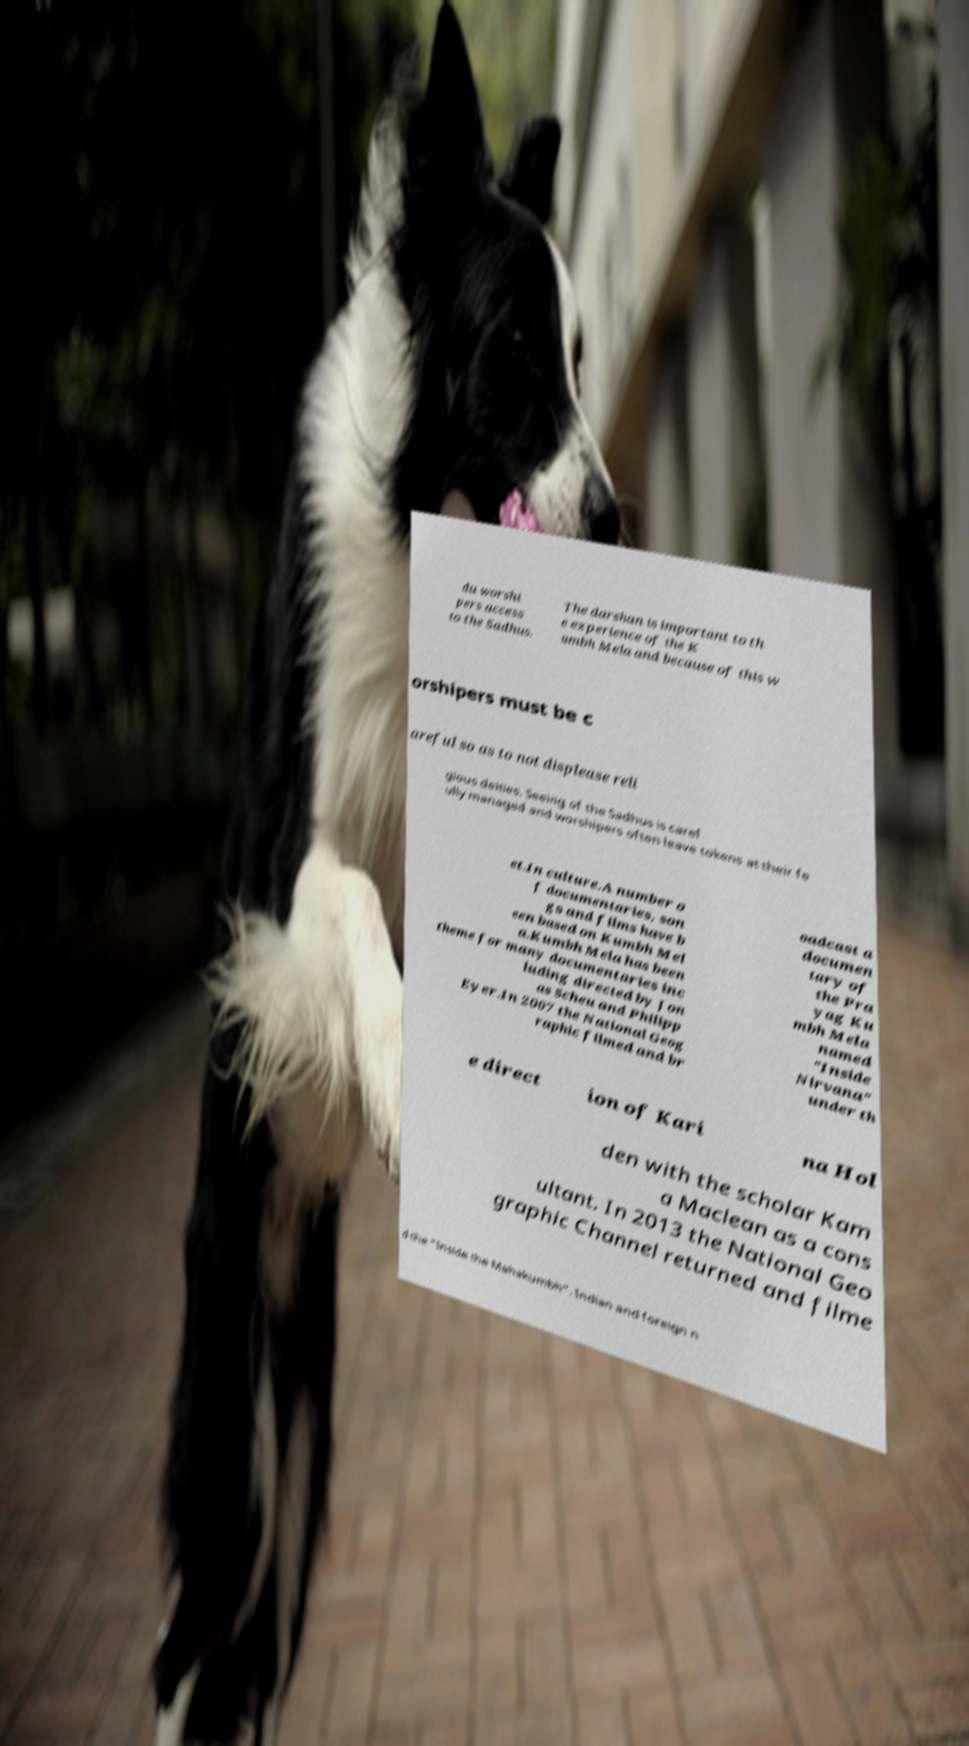Please identify and transcribe the text found in this image. du worshi pers access to the Sadhus. The darshan is important to th e experience of the K umbh Mela and because of this w orshipers must be c areful so as to not displease reli gious deities. Seeing of the Sadhus is caref ully managed and worshipers often leave tokens at their fe et.In culture.A number o f documentaries, son gs and films have b een based on Kumbh Mel a.Kumbh Mela has been theme for many documentaries inc luding directed by Jon as Scheu and Philipp Eyer.In 2007 the National Geog raphic filmed and br oadcast a documen tary of the Pra yag Ku mbh Mela named "Inside Nirvana" under th e direct ion of Kari na Hol den with the scholar Kam a Maclean as a cons ultant. In 2013 the National Geo graphic Channel returned and filme d the "Inside the Mahakumbh". Indian and foreign n 